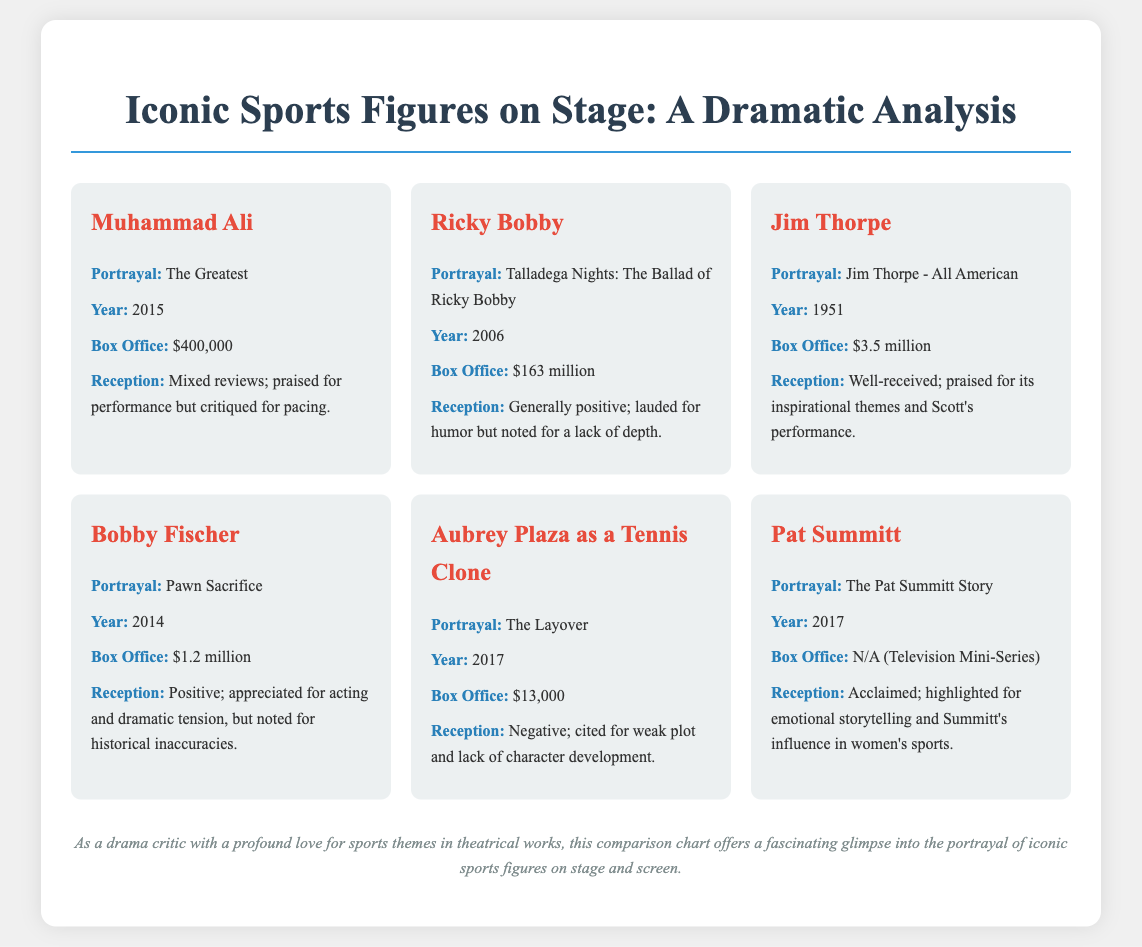What is the box office revenue for "Talladega Nights: The Ballad of Ricky Bobby"? The box office revenue for "Talladega Nights: The Ballad of Ricky Bobby" is mentioned in the document as $163 million.
Answer: $163 million Which iconic sports figure was portrayed in the 2015 drama "The Greatest"? The document indicates that Muhammad Ali was portrayed in the 2015 drama "The Greatest."
Answer: Muhammad Ali What is the reception of the portrayal of Bobby Fischer in "Pawn Sacrifice"? The reception of Bobby Fischer's portrayal is described as positive, appreciated for acting and dramatic tension.
Answer: Positive How much did "Jim Thorpe - All American" earn at the box office? The document states that "Jim Thorpe - All American" earned $3.5 million at the box office.
Answer: $3.5 million What year was the television mini-series "The Pat Summitt Story" released? The document specifies that "The Pat Summitt Story" was released in 2017.
Answer: 2017 Which character's portrayal received negative reception due to a weak plot? The portrayal of Aubrey Plaza as a Tennis Clone is noted to have received negative reception for weak plot and lack of character development.
Answer: Aubrey Plaza as a Tennis Clone What was the box office revenue for the portrayal of Muhammad Ali? The box office revenue for the portrayal of Muhammad Ali in "The Greatest" is listed as $400,000.
Answer: $400,000 In what context is the reception for the portrayal of Pat Summitt described? The reception for Pat Summitt's portrayal is described as acclaimed, highlighting emotional storytelling.
Answer: Acclaimed 